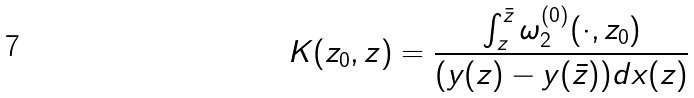Convert formula to latex. <formula><loc_0><loc_0><loc_500><loc_500>K ( z _ { 0 } , z ) = \frac { \int ^ { \bar { z } } _ { z } \omega ^ { ( 0 ) } _ { 2 } ( \cdot , z _ { 0 } ) } { ( y ( z ) - y ( \bar { z } ) ) d x ( z ) }</formula> 